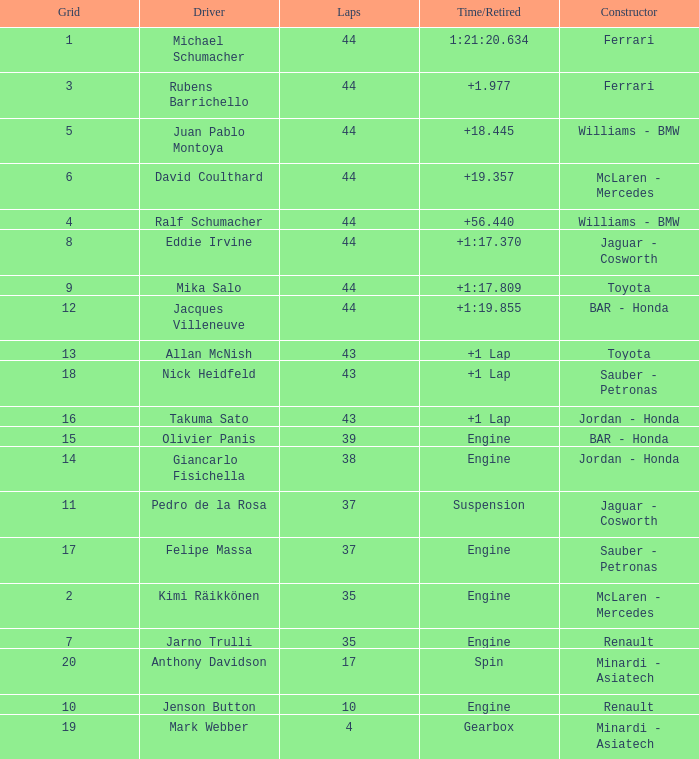What was the time of the driver on grid 3? 1.977. 